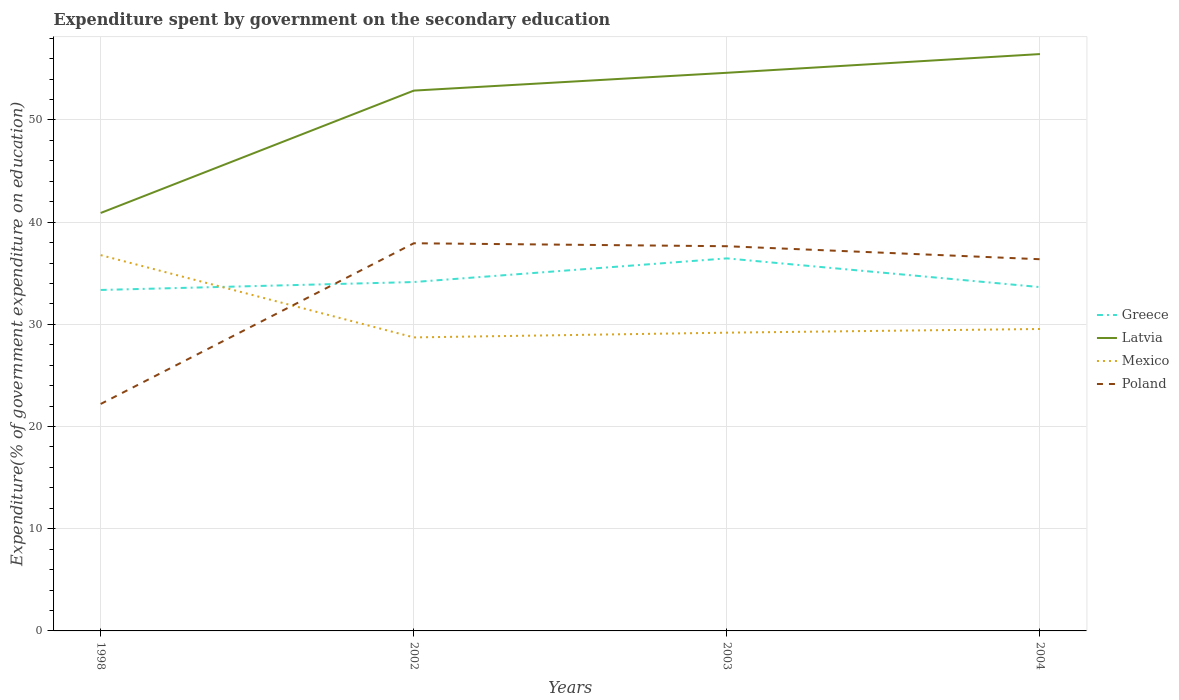How many different coloured lines are there?
Your answer should be compact. 4. Does the line corresponding to Mexico intersect with the line corresponding to Poland?
Offer a terse response. Yes. Across all years, what is the maximum expenditure spent by government on the secondary education in Latvia?
Give a very brief answer. 40.9. What is the total expenditure spent by government on the secondary education in Mexico in the graph?
Offer a very short reply. -0.46. What is the difference between the highest and the second highest expenditure spent by government on the secondary education in Greece?
Ensure brevity in your answer.  3.09. What is the difference between the highest and the lowest expenditure spent by government on the secondary education in Poland?
Offer a terse response. 3. Is the expenditure spent by government on the secondary education in Latvia strictly greater than the expenditure spent by government on the secondary education in Greece over the years?
Ensure brevity in your answer.  No. How many years are there in the graph?
Keep it short and to the point. 4. Does the graph contain grids?
Make the answer very short. Yes. Where does the legend appear in the graph?
Give a very brief answer. Center right. What is the title of the graph?
Offer a terse response. Expenditure spent by government on the secondary education. Does "Fiji" appear as one of the legend labels in the graph?
Your answer should be compact. No. What is the label or title of the X-axis?
Give a very brief answer. Years. What is the label or title of the Y-axis?
Offer a very short reply. Expenditure(% of government expenditure on education). What is the Expenditure(% of government expenditure on education) of Greece in 1998?
Give a very brief answer. 33.36. What is the Expenditure(% of government expenditure on education) in Latvia in 1998?
Make the answer very short. 40.9. What is the Expenditure(% of government expenditure on education) in Mexico in 1998?
Make the answer very short. 36.77. What is the Expenditure(% of government expenditure on education) in Poland in 1998?
Ensure brevity in your answer.  22.21. What is the Expenditure(% of government expenditure on education) of Greece in 2002?
Make the answer very short. 34.14. What is the Expenditure(% of government expenditure on education) in Latvia in 2002?
Keep it short and to the point. 52.87. What is the Expenditure(% of government expenditure on education) of Mexico in 2002?
Provide a short and direct response. 28.72. What is the Expenditure(% of government expenditure on education) in Poland in 2002?
Your response must be concise. 37.93. What is the Expenditure(% of government expenditure on education) of Greece in 2003?
Offer a terse response. 36.45. What is the Expenditure(% of government expenditure on education) in Latvia in 2003?
Your answer should be very brief. 54.61. What is the Expenditure(% of government expenditure on education) of Mexico in 2003?
Offer a terse response. 29.18. What is the Expenditure(% of government expenditure on education) of Poland in 2003?
Provide a short and direct response. 37.64. What is the Expenditure(% of government expenditure on education) in Greece in 2004?
Provide a succinct answer. 33.64. What is the Expenditure(% of government expenditure on education) of Latvia in 2004?
Your answer should be very brief. 56.45. What is the Expenditure(% of government expenditure on education) in Mexico in 2004?
Your answer should be very brief. 29.54. What is the Expenditure(% of government expenditure on education) of Poland in 2004?
Provide a short and direct response. 36.37. Across all years, what is the maximum Expenditure(% of government expenditure on education) in Greece?
Provide a succinct answer. 36.45. Across all years, what is the maximum Expenditure(% of government expenditure on education) in Latvia?
Keep it short and to the point. 56.45. Across all years, what is the maximum Expenditure(% of government expenditure on education) in Mexico?
Your answer should be very brief. 36.77. Across all years, what is the maximum Expenditure(% of government expenditure on education) of Poland?
Your response must be concise. 37.93. Across all years, what is the minimum Expenditure(% of government expenditure on education) in Greece?
Keep it short and to the point. 33.36. Across all years, what is the minimum Expenditure(% of government expenditure on education) in Latvia?
Your response must be concise. 40.9. Across all years, what is the minimum Expenditure(% of government expenditure on education) in Mexico?
Make the answer very short. 28.72. Across all years, what is the minimum Expenditure(% of government expenditure on education) in Poland?
Your answer should be very brief. 22.21. What is the total Expenditure(% of government expenditure on education) in Greece in the graph?
Provide a short and direct response. 137.6. What is the total Expenditure(% of government expenditure on education) of Latvia in the graph?
Provide a succinct answer. 204.83. What is the total Expenditure(% of government expenditure on education) in Mexico in the graph?
Give a very brief answer. 124.22. What is the total Expenditure(% of government expenditure on education) of Poland in the graph?
Offer a very short reply. 134.15. What is the difference between the Expenditure(% of government expenditure on education) in Greece in 1998 and that in 2002?
Provide a succinct answer. -0.78. What is the difference between the Expenditure(% of government expenditure on education) in Latvia in 1998 and that in 2002?
Offer a very short reply. -11.97. What is the difference between the Expenditure(% of government expenditure on education) in Mexico in 1998 and that in 2002?
Offer a very short reply. 8.05. What is the difference between the Expenditure(% of government expenditure on education) in Poland in 1998 and that in 2002?
Provide a short and direct response. -15.73. What is the difference between the Expenditure(% of government expenditure on education) in Greece in 1998 and that in 2003?
Make the answer very short. -3.09. What is the difference between the Expenditure(% of government expenditure on education) in Latvia in 1998 and that in 2003?
Your answer should be compact. -13.72. What is the difference between the Expenditure(% of government expenditure on education) in Mexico in 1998 and that in 2003?
Make the answer very short. 7.59. What is the difference between the Expenditure(% of government expenditure on education) of Poland in 1998 and that in 2003?
Provide a succinct answer. -15.44. What is the difference between the Expenditure(% of government expenditure on education) of Greece in 1998 and that in 2004?
Ensure brevity in your answer.  -0.28. What is the difference between the Expenditure(% of government expenditure on education) in Latvia in 1998 and that in 2004?
Your answer should be very brief. -15.55. What is the difference between the Expenditure(% of government expenditure on education) of Mexico in 1998 and that in 2004?
Your response must be concise. 7.23. What is the difference between the Expenditure(% of government expenditure on education) in Poland in 1998 and that in 2004?
Your answer should be very brief. -14.16. What is the difference between the Expenditure(% of government expenditure on education) of Greece in 2002 and that in 2003?
Provide a succinct answer. -2.31. What is the difference between the Expenditure(% of government expenditure on education) of Latvia in 2002 and that in 2003?
Offer a very short reply. -1.74. What is the difference between the Expenditure(% of government expenditure on education) of Mexico in 2002 and that in 2003?
Provide a succinct answer. -0.46. What is the difference between the Expenditure(% of government expenditure on education) of Poland in 2002 and that in 2003?
Your answer should be very brief. 0.29. What is the difference between the Expenditure(% of government expenditure on education) in Greece in 2002 and that in 2004?
Offer a very short reply. 0.49. What is the difference between the Expenditure(% of government expenditure on education) in Latvia in 2002 and that in 2004?
Provide a short and direct response. -3.58. What is the difference between the Expenditure(% of government expenditure on education) in Mexico in 2002 and that in 2004?
Provide a short and direct response. -0.82. What is the difference between the Expenditure(% of government expenditure on education) in Poland in 2002 and that in 2004?
Offer a terse response. 1.56. What is the difference between the Expenditure(% of government expenditure on education) in Greece in 2003 and that in 2004?
Provide a short and direct response. 2.81. What is the difference between the Expenditure(% of government expenditure on education) of Latvia in 2003 and that in 2004?
Offer a terse response. -1.83. What is the difference between the Expenditure(% of government expenditure on education) in Mexico in 2003 and that in 2004?
Provide a succinct answer. -0.36. What is the difference between the Expenditure(% of government expenditure on education) in Poland in 2003 and that in 2004?
Provide a short and direct response. 1.27. What is the difference between the Expenditure(% of government expenditure on education) of Greece in 1998 and the Expenditure(% of government expenditure on education) of Latvia in 2002?
Keep it short and to the point. -19.51. What is the difference between the Expenditure(% of government expenditure on education) of Greece in 1998 and the Expenditure(% of government expenditure on education) of Mexico in 2002?
Keep it short and to the point. 4.64. What is the difference between the Expenditure(% of government expenditure on education) of Greece in 1998 and the Expenditure(% of government expenditure on education) of Poland in 2002?
Make the answer very short. -4.57. What is the difference between the Expenditure(% of government expenditure on education) of Latvia in 1998 and the Expenditure(% of government expenditure on education) of Mexico in 2002?
Offer a terse response. 12.18. What is the difference between the Expenditure(% of government expenditure on education) in Latvia in 1998 and the Expenditure(% of government expenditure on education) in Poland in 2002?
Keep it short and to the point. 2.96. What is the difference between the Expenditure(% of government expenditure on education) in Mexico in 1998 and the Expenditure(% of government expenditure on education) in Poland in 2002?
Ensure brevity in your answer.  -1.16. What is the difference between the Expenditure(% of government expenditure on education) in Greece in 1998 and the Expenditure(% of government expenditure on education) in Latvia in 2003?
Your response must be concise. -21.25. What is the difference between the Expenditure(% of government expenditure on education) of Greece in 1998 and the Expenditure(% of government expenditure on education) of Mexico in 2003?
Provide a short and direct response. 4.18. What is the difference between the Expenditure(% of government expenditure on education) of Greece in 1998 and the Expenditure(% of government expenditure on education) of Poland in 2003?
Give a very brief answer. -4.28. What is the difference between the Expenditure(% of government expenditure on education) of Latvia in 1998 and the Expenditure(% of government expenditure on education) of Mexico in 2003?
Keep it short and to the point. 11.71. What is the difference between the Expenditure(% of government expenditure on education) of Latvia in 1998 and the Expenditure(% of government expenditure on education) of Poland in 2003?
Keep it short and to the point. 3.25. What is the difference between the Expenditure(% of government expenditure on education) in Mexico in 1998 and the Expenditure(% of government expenditure on education) in Poland in 2003?
Offer a very short reply. -0.87. What is the difference between the Expenditure(% of government expenditure on education) of Greece in 1998 and the Expenditure(% of government expenditure on education) of Latvia in 2004?
Provide a short and direct response. -23.08. What is the difference between the Expenditure(% of government expenditure on education) of Greece in 1998 and the Expenditure(% of government expenditure on education) of Mexico in 2004?
Ensure brevity in your answer.  3.82. What is the difference between the Expenditure(% of government expenditure on education) in Greece in 1998 and the Expenditure(% of government expenditure on education) in Poland in 2004?
Offer a terse response. -3.01. What is the difference between the Expenditure(% of government expenditure on education) in Latvia in 1998 and the Expenditure(% of government expenditure on education) in Mexico in 2004?
Provide a short and direct response. 11.35. What is the difference between the Expenditure(% of government expenditure on education) in Latvia in 1998 and the Expenditure(% of government expenditure on education) in Poland in 2004?
Your response must be concise. 4.53. What is the difference between the Expenditure(% of government expenditure on education) in Mexico in 1998 and the Expenditure(% of government expenditure on education) in Poland in 2004?
Make the answer very short. 0.4. What is the difference between the Expenditure(% of government expenditure on education) of Greece in 2002 and the Expenditure(% of government expenditure on education) of Latvia in 2003?
Give a very brief answer. -20.48. What is the difference between the Expenditure(% of government expenditure on education) of Greece in 2002 and the Expenditure(% of government expenditure on education) of Mexico in 2003?
Ensure brevity in your answer.  4.95. What is the difference between the Expenditure(% of government expenditure on education) of Greece in 2002 and the Expenditure(% of government expenditure on education) of Poland in 2003?
Make the answer very short. -3.5. What is the difference between the Expenditure(% of government expenditure on education) of Latvia in 2002 and the Expenditure(% of government expenditure on education) of Mexico in 2003?
Offer a very short reply. 23.69. What is the difference between the Expenditure(% of government expenditure on education) in Latvia in 2002 and the Expenditure(% of government expenditure on education) in Poland in 2003?
Offer a terse response. 15.23. What is the difference between the Expenditure(% of government expenditure on education) in Mexico in 2002 and the Expenditure(% of government expenditure on education) in Poland in 2003?
Make the answer very short. -8.92. What is the difference between the Expenditure(% of government expenditure on education) in Greece in 2002 and the Expenditure(% of government expenditure on education) in Latvia in 2004?
Offer a terse response. -22.31. What is the difference between the Expenditure(% of government expenditure on education) in Greece in 2002 and the Expenditure(% of government expenditure on education) in Mexico in 2004?
Ensure brevity in your answer.  4.59. What is the difference between the Expenditure(% of government expenditure on education) in Greece in 2002 and the Expenditure(% of government expenditure on education) in Poland in 2004?
Give a very brief answer. -2.23. What is the difference between the Expenditure(% of government expenditure on education) in Latvia in 2002 and the Expenditure(% of government expenditure on education) in Mexico in 2004?
Your answer should be very brief. 23.33. What is the difference between the Expenditure(% of government expenditure on education) in Latvia in 2002 and the Expenditure(% of government expenditure on education) in Poland in 2004?
Provide a short and direct response. 16.5. What is the difference between the Expenditure(% of government expenditure on education) of Mexico in 2002 and the Expenditure(% of government expenditure on education) of Poland in 2004?
Provide a short and direct response. -7.65. What is the difference between the Expenditure(% of government expenditure on education) of Greece in 2003 and the Expenditure(% of government expenditure on education) of Latvia in 2004?
Provide a short and direct response. -19.99. What is the difference between the Expenditure(% of government expenditure on education) of Greece in 2003 and the Expenditure(% of government expenditure on education) of Mexico in 2004?
Provide a short and direct response. 6.91. What is the difference between the Expenditure(% of government expenditure on education) in Greece in 2003 and the Expenditure(% of government expenditure on education) in Poland in 2004?
Offer a very short reply. 0.08. What is the difference between the Expenditure(% of government expenditure on education) in Latvia in 2003 and the Expenditure(% of government expenditure on education) in Mexico in 2004?
Make the answer very short. 25.07. What is the difference between the Expenditure(% of government expenditure on education) in Latvia in 2003 and the Expenditure(% of government expenditure on education) in Poland in 2004?
Offer a terse response. 18.24. What is the difference between the Expenditure(% of government expenditure on education) in Mexico in 2003 and the Expenditure(% of government expenditure on education) in Poland in 2004?
Offer a very short reply. -7.19. What is the average Expenditure(% of government expenditure on education) in Greece per year?
Provide a succinct answer. 34.4. What is the average Expenditure(% of government expenditure on education) in Latvia per year?
Provide a succinct answer. 51.21. What is the average Expenditure(% of government expenditure on education) in Mexico per year?
Your answer should be very brief. 31.06. What is the average Expenditure(% of government expenditure on education) in Poland per year?
Your answer should be very brief. 33.54. In the year 1998, what is the difference between the Expenditure(% of government expenditure on education) in Greece and Expenditure(% of government expenditure on education) in Latvia?
Give a very brief answer. -7.53. In the year 1998, what is the difference between the Expenditure(% of government expenditure on education) of Greece and Expenditure(% of government expenditure on education) of Mexico?
Provide a succinct answer. -3.41. In the year 1998, what is the difference between the Expenditure(% of government expenditure on education) in Greece and Expenditure(% of government expenditure on education) in Poland?
Offer a terse response. 11.16. In the year 1998, what is the difference between the Expenditure(% of government expenditure on education) in Latvia and Expenditure(% of government expenditure on education) in Mexico?
Ensure brevity in your answer.  4.12. In the year 1998, what is the difference between the Expenditure(% of government expenditure on education) in Latvia and Expenditure(% of government expenditure on education) in Poland?
Give a very brief answer. 18.69. In the year 1998, what is the difference between the Expenditure(% of government expenditure on education) in Mexico and Expenditure(% of government expenditure on education) in Poland?
Offer a terse response. 14.57. In the year 2002, what is the difference between the Expenditure(% of government expenditure on education) in Greece and Expenditure(% of government expenditure on education) in Latvia?
Offer a very short reply. -18.73. In the year 2002, what is the difference between the Expenditure(% of government expenditure on education) in Greece and Expenditure(% of government expenditure on education) in Mexico?
Give a very brief answer. 5.42. In the year 2002, what is the difference between the Expenditure(% of government expenditure on education) in Greece and Expenditure(% of government expenditure on education) in Poland?
Keep it short and to the point. -3.8. In the year 2002, what is the difference between the Expenditure(% of government expenditure on education) of Latvia and Expenditure(% of government expenditure on education) of Mexico?
Provide a short and direct response. 24.15. In the year 2002, what is the difference between the Expenditure(% of government expenditure on education) in Latvia and Expenditure(% of government expenditure on education) in Poland?
Provide a short and direct response. 14.94. In the year 2002, what is the difference between the Expenditure(% of government expenditure on education) of Mexico and Expenditure(% of government expenditure on education) of Poland?
Provide a succinct answer. -9.21. In the year 2003, what is the difference between the Expenditure(% of government expenditure on education) of Greece and Expenditure(% of government expenditure on education) of Latvia?
Your answer should be very brief. -18.16. In the year 2003, what is the difference between the Expenditure(% of government expenditure on education) of Greece and Expenditure(% of government expenditure on education) of Mexico?
Give a very brief answer. 7.27. In the year 2003, what is the difference between the Expenditure(% of government expenditure on education) of Greece and Expenditure(% of government expenditure on education) of Poland?
Your response must be concise. -1.19. In the year 2003, what is the difference between the Expenditure(% of government expenditure on education) in Latvia and Expenditure(% of government expenditure on education) in Mexico?
Give a very brief answer. 25.43. In the year 2003, what is the difference between the Expenditure(% of government expenditure on education) in Latvia and Expenditure(% of government expenditure on education) in Poland?
Your answer should be compact. 16.97. In the year 2003, what is the difference between the Expenditure(% of government expenditure on education) in Mexico and Expenditure(% of government expenditure on education) in Poland?
Make the answer very short. -8.46. In the year 2004, what is the difference between the Expenditure(% of government expenditure on education) in Greece and Expenditure(% of government expenditure on education) in Latvia?
Provide a short and direct response. -22.8. In the year 2004, what is the difference between the Expenditure(% of government expenditure on education) of Greece and Expenditure(% of government expenditure on education) of Mexico?
Your answer should be compact. 4.1. In the year 2004, what is the difference between the Expenditure(% of government expenditure on education) of Greece and Expenditure(% of government expenditure on education) of Poland?
Offer a terse response. -2.73. In the year 2004, what is the difference between the Expenditure(% of government expenditure on education) in Latvia and Expenditure(% of government expenditure on education) in Mexico?
Provide a succinct answer. 26.9. In the year 2004, what is the difference between the Expenditure(% of government expenditure on education) in Latvia and Expenditure(% of government expenditure on education) in Poland?
Provide a short and direct response. 20.07. In the year 2004, what is the difference between the Expenditure(% of government expenditure on education) in Mexico and Expenditure(% of government expenditure on education) in Poland?
Give a very brief answer. -6.83. What is the ratio of the Expenditure(% of government expenditure on education) in Greece in 1998 to that in 2002?
Your response must be concise. 0.98. What is the ratio of the Expenditure(% of government expenditure on education) in Latvia in 1998 to that in 2002?
Offer a very short reply. 0.77. What is the ratio of the Expenditure(% of government expenditure on education) of Mexico in 1998 to that in 2002?
Your answer should be very brief. 1.28. What is the ratio of the Expenditure(% of government expenditure on education) of Poland in 1998 to that in 2002?
Offer a very short reply. 0.59. What is the ratio of the Expenditure(% of government expenditure on education) in Greece in 1998 to that in 2003?
Offer a very short reply. 0.92. What is the ratio of the Expenditure(% of government expenditure on education) in Latvia in 1998 to that in 2003?
Your answer should be very brief. 0.75. What is the ratio of the Expenditure(% of government expenditure on education) of Mexico in 1998 to that in 2003?
Your answer should be compact. 1.26. What is the ratio of the Expenditure(% of government expenditure on education) of Poland in 1998 to that in 2003?
Offer a very short reply. 0.59. What is the ratio of the Expenditure(% of government expenditure on education) of Greece in 1998 to that in 2004?
Give a very brief answer. 0.99. What is the ratio of the Expenditure(% of government expenditure on education) of Latvia in 1998 to that in 2004?
Offer a very short reply. 0.72. What is the ratio of the Expenditure(% of government expenditure on education) of Mexico in 1998 to that in 2004?
Ensure brevity in your answer.  1.24. What is the ratio of the Expenditure(% of government expenditure on education) in Poland in 1998 to that in 2004?
Offer a terse response. 0.61. What is the ratio of the Expenditure(% of government expenditure on education) in Greece in 2002 to that in 2003?
Offer a very short reply. 0.94. What is the ratio of the Expenditure(% of government expenditure on education) of Latvia in 2002 to that in 2003?
Offer a terse response. 0.97. What is the ratio of the Expenditure(% of government expenditure on education) of Mexico in 2002 to that in 2003?
Keep it short and to the point. 0.98. What is the ratio of the Expenditure(% of government expenditure on education) of Poland in 2002 to that in 2003?
Your answer should be compact. 1.01. What is the ratio of the Expenditure(% of government expenditure on education) of Greece in 2002 to that in 2004?
Offer a very short reply. 1.01. What is the ratio of the Expenditure(% of government expenditure on education) of Latvia in 2002 to that in 2004?
Make the answer very short. 0.94. What is the ratio of the Expenditure(% of government expenditure on education) in Mexico in 2002 to that in 2004?
Keep it short and to the point. 0.97. What is the ratio of the Expenditure(% of government expenditure on education) in Poland in 2002 to that in 2004?
Keep it short and to the point. 1.04. What is the ratio of the Expenditure(% of government expenditure on education) of Greece in 2003 to that in 2004?
Provide a succinct answer. 1.08. What is the ratio of the Expenditure(% of government expenditure on education) of Latvia in 2003 to that in 2004?
Your answer should be compact. 0.97. What is the ratio of the Expenditure(% of government expenditure on education) of Poland in 2003 to that in 2004?
Keep it short and to the point. 1.03. What is the difference between the highest and the second highest Expenditure(% of government expenditure on education) in Greece?
Make the answer very short. 2.31. What is the difference between the highest and the second highest Expenditure(% of government expenditure on education) in Latvia?
Give a very brief answer. 1.83. What is the difference between the highest and the second highest Expenditure(% of government expenditure on education) of Mexico?
Offer a terse response. 7.23. What is the difference between the highest and the second highest Expenditure(% of government expenditure on education) of Poland?
Your answer should be very brief. 0.29. What is the difference between the highest and the lowest Expenditure(% of government expenditure on education) in Greece?
Ensure brevity in your answer.  3.09. What is the difference between the highest and the lowest Expenditure(% of government expenditure on education) of Latvia?
Your response must be concise. 15.55. What is the difference between the highest and the lowest Expenditure(% of government expenditure on education) of Mexico?
Keep it short and to the point. 8.05. What is the difference between the highest and the lowest Expenditure(% of government expenditure on education) of Poland?
Your answer should be compact. 15.73. 